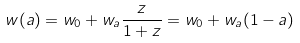Convert formula to latex. <formula><loc_0><loc_0><loc_500><loc_500>w ( a ) = w _ { 0 } + w _ { a } \frac { z } { 1 + z } = w _ { 0 } + w _ { a } ( 1 - a )</formula> 